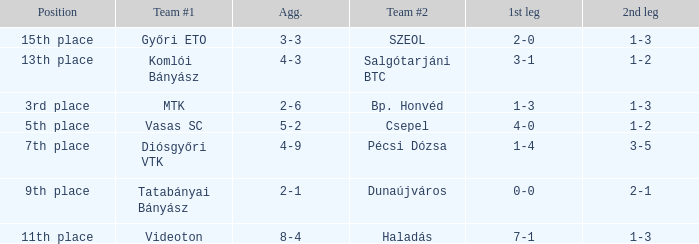What is the 2nd leg of the 4-9 agg.? 3-5. 